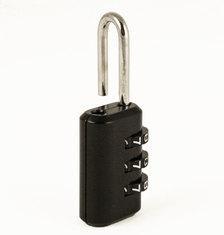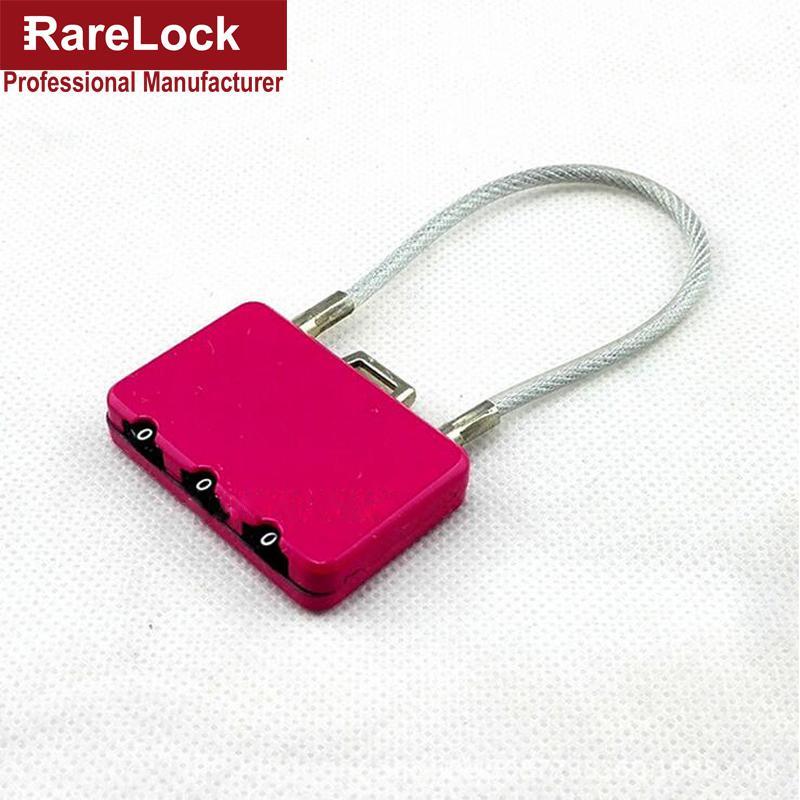The first image is the image on the left, the second image is the image on the right. Considering the images on both sides, is "Of two locks, one is all metal with sliding number belts on the side, while the other has the number belts in a different position and a white cord lock loop." valid? Answer yes or no. Yes. The first image is the image on the left, the second image is the image on the right. For the images shown, is this caption "The lock in the image on the right is silver metal." true? Answer yes or no. No. 